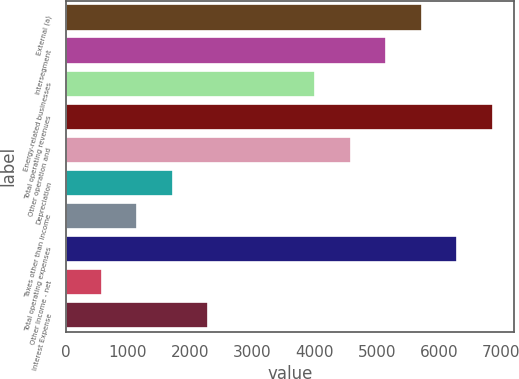Convert chart to OTSL. <chart><loc_0><loc_0><loc_500><loc_500><bar_chart><fcel>External (a)<fcel>Intersegment<fcel>Energy-related businesses<fcel>Total operating revenues<fcel>Other operation and<fcel>Depreciation<fcel>Taxes other than income<fcel>Total operating expenses<fcel>Other Income - net<fcel>Interest Expense<nl><fcel>5723<fcel>5150.9<fcel>4006.7<fcel>6867.2<fcel>4578.8<fcel>1718.3<fcel>1146.2<fcel>6295.1<fcel>574.1<fcel>2290.4<nl></chart> 